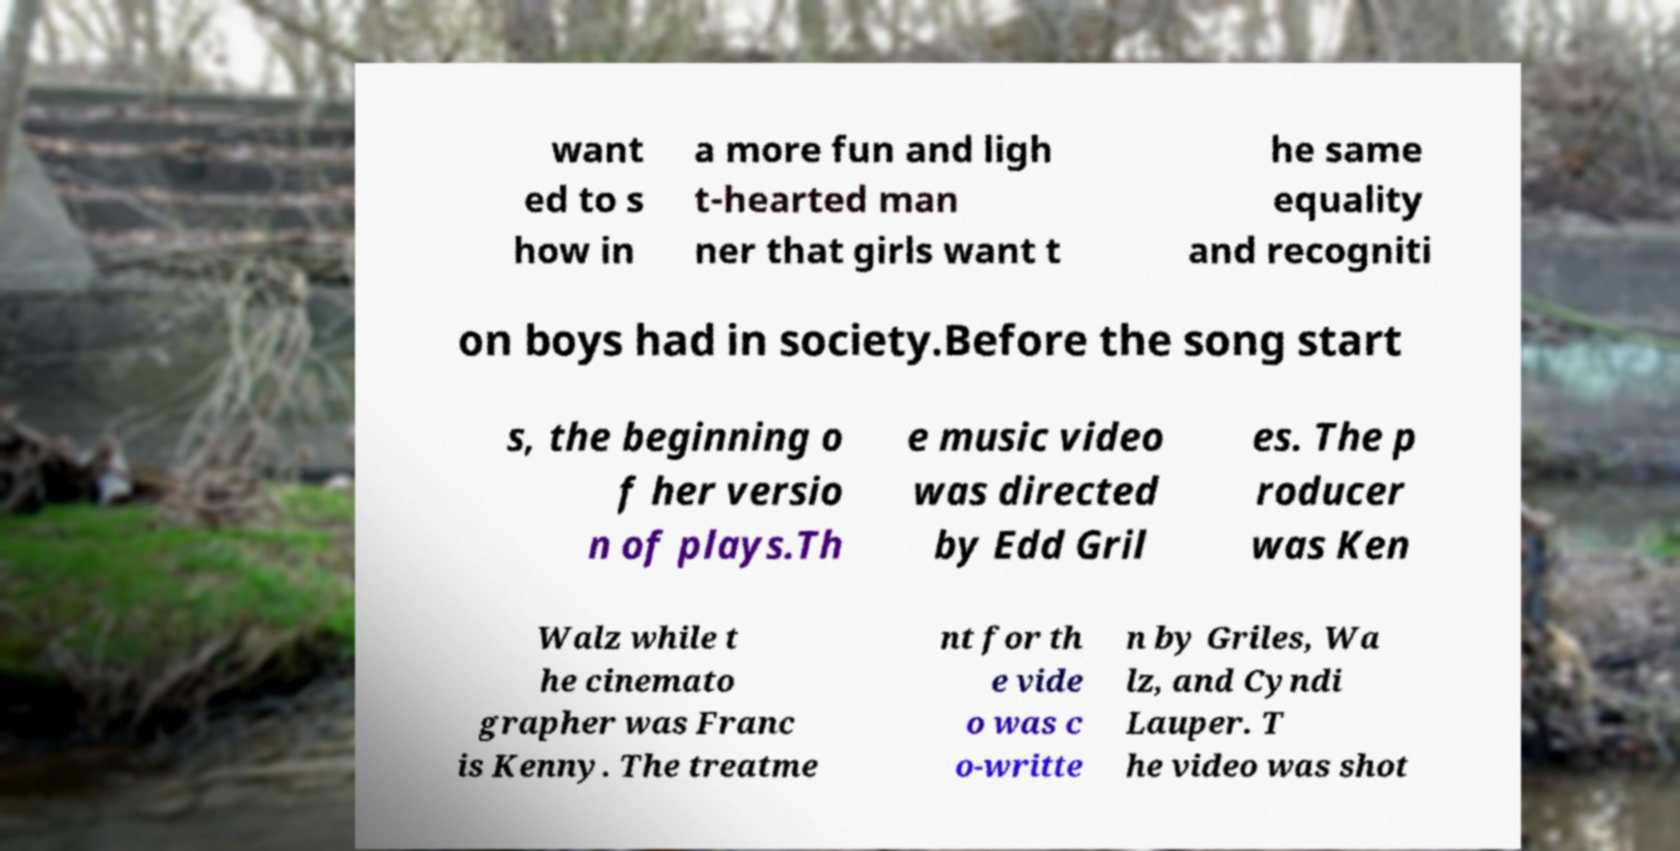For documentation purposes, I need the text within this image transcribed. Could you provide that? want ed to s how in a more fun and ligh t-hearted man ner that girls want t he same equality and recogniti on boys had in society.Before the song start s, the beginning o f her versio n of plays.Th e music video was directed by Edd Gril es. The p roducer was Ken Walz while t he cinemato grapher was Franc is Kenny. The treatme nt for th e vide o was c o-writte n by Griles, Wa lz, and Cyndi Lauper. T he video was shot 